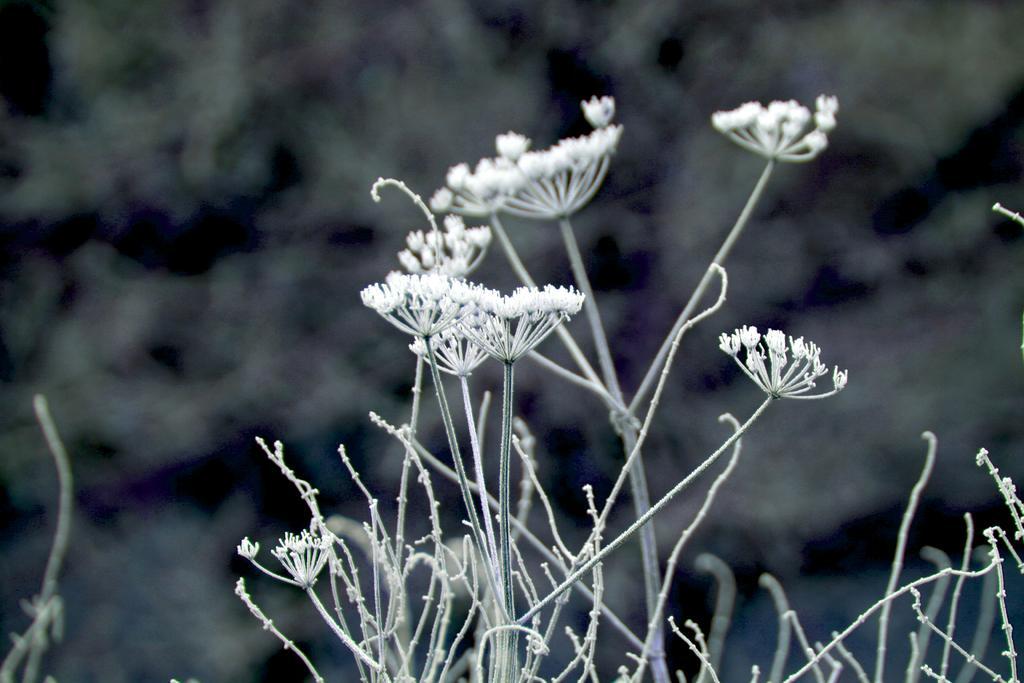Can you describe this image briefly? In this image, I can see the plants with the tiny flowers. The background looks blurry. 